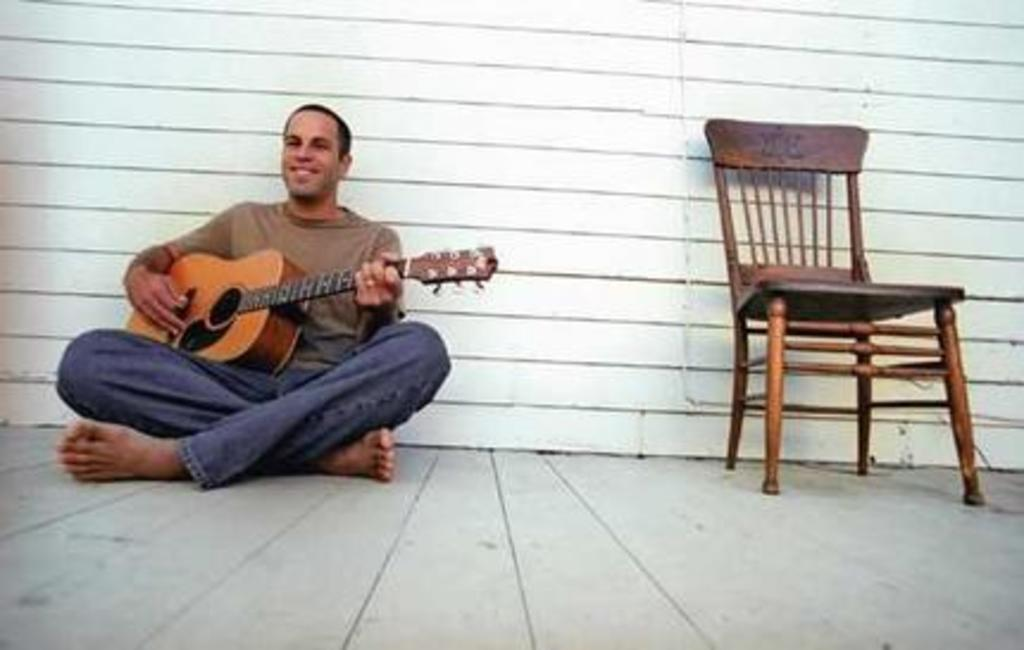What is the man in the image doing? The man is playing a guitar in the image. Where is the man sitting? The man is sitting on the floor. What object is to the man's right side? There is a wooden chair to the man's right side. What can be seen in the background of the image? There is a wall in the background of the image. What type of flag is visible on the man's guitar in the image? There is no flag visible on the man's guitar in the image. What mode of transportation can be seen passing by in the image? There are no trains or any other mode of transportation present in the image. 